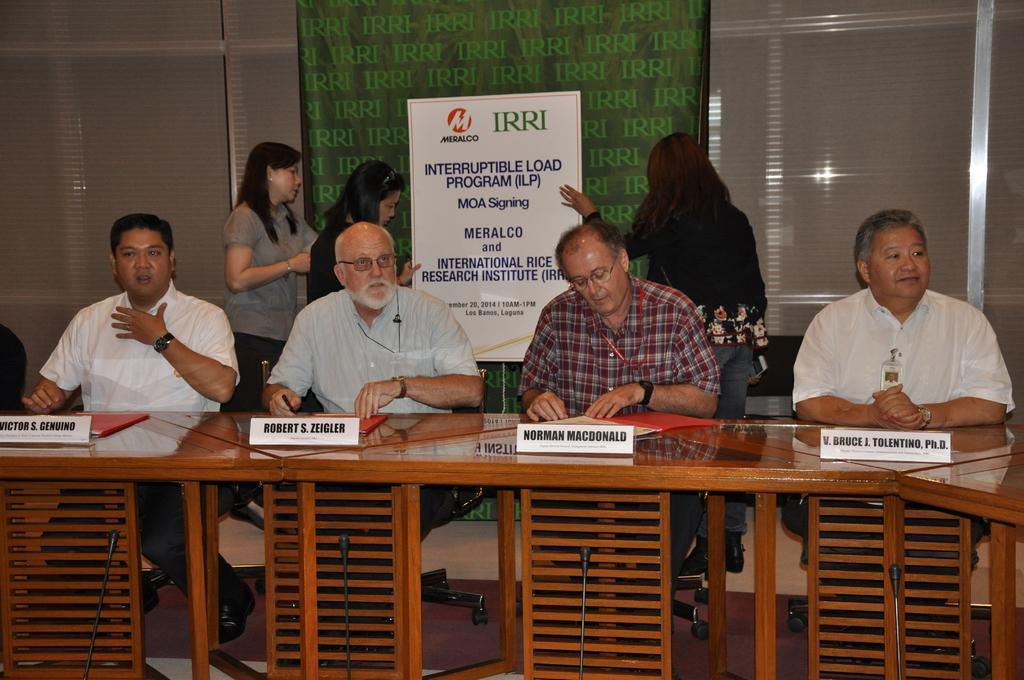Could you give a brief overview of what you see in this image? In this picture we can see for men are sitting on chairs in front of a table, there are name boards and files present on the table, in the background there are three women standing, we can see a board and a banner in the middle, there is some text on the board, we can also see window blinds in the background. 